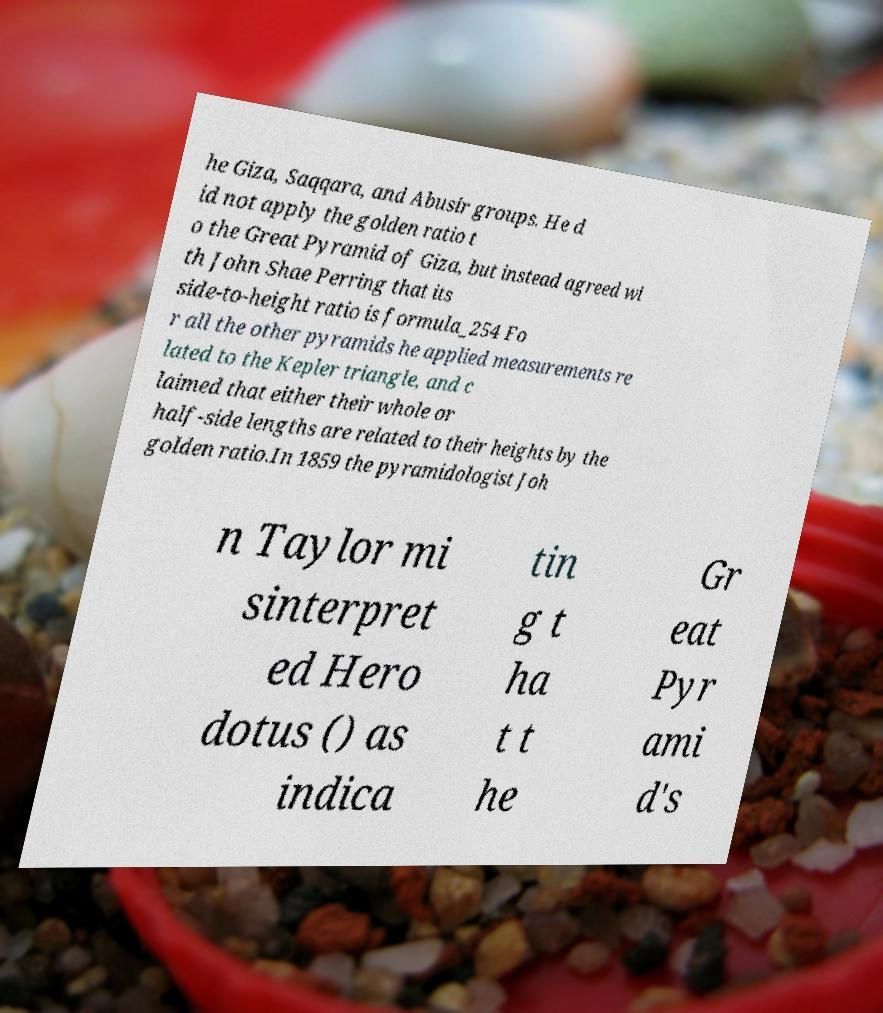What messages or text are displayed in this image? I need them in a readable, typed format. he Giza, Saqqara, and Abusir groups. He d id not apply the golden ratio t o the Great Pyramid of Giza, but instead agreed wi th John Shae Perring that its side-to-height ratio is formula_254 Fo r all the other pyramids he applied measurements re lated to the Kepler triangle, and c laimed that either their whole or half-side lengths are related to their heights by the golden ratio.In 1859 the pyramidologist Joh n Taylor mi sinterpret ed Hero dotus () as indica tin g t ha t t he Gr eat Pyr ami d's 